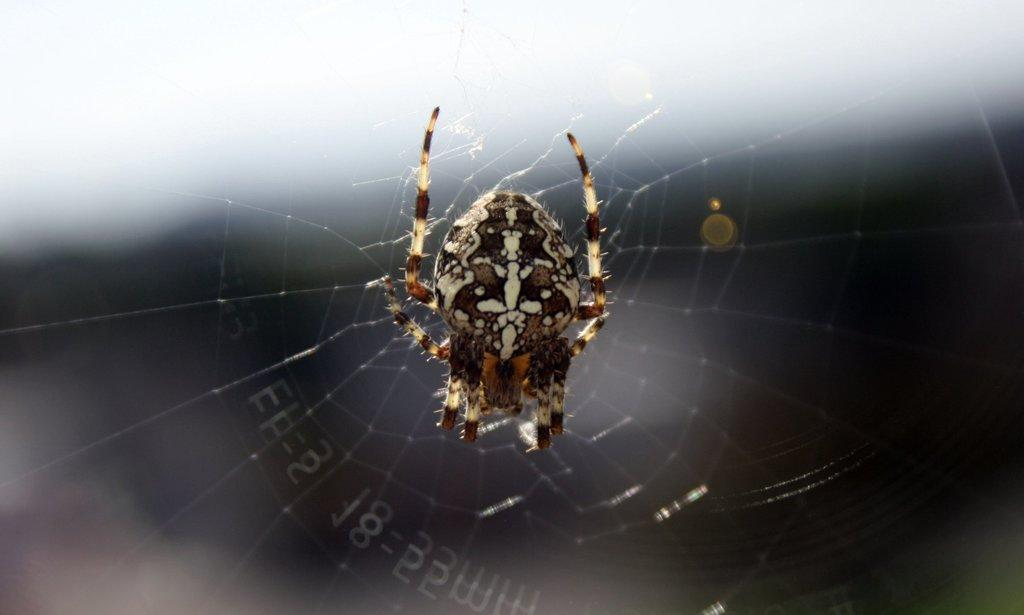What is the main subject of the image? There is a spider in the image. Where is the spider located? The spider is on a spider web. What type of sense does the giraffe have in the image? There is no giraffe present in the image, so it is not possible to determine what type of sense it might have. 